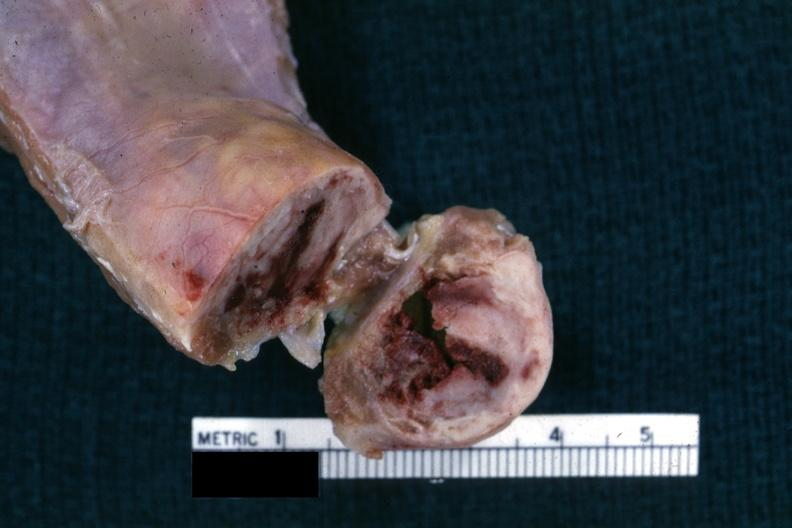s joints present?
Answer the question using a single word or phrase. Yes 